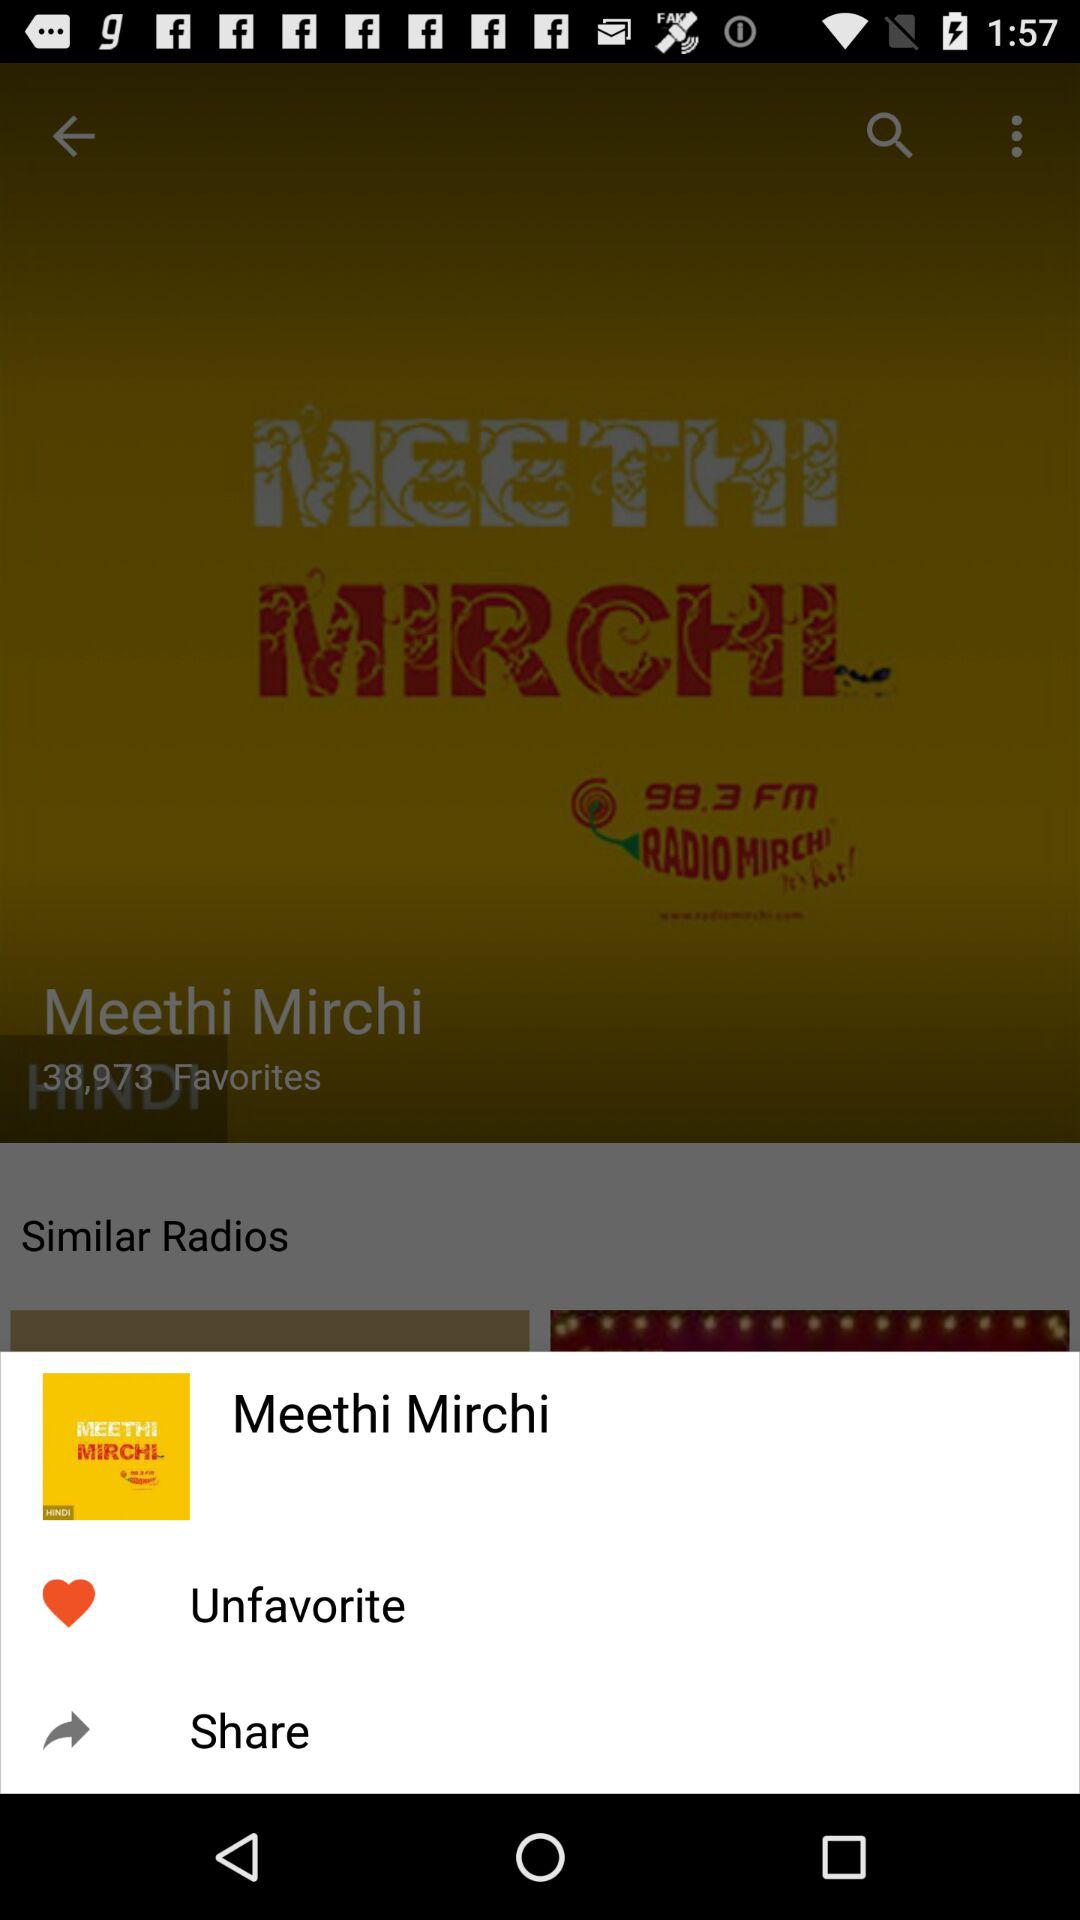How many people have marked "Meethi Mirchi" as a favorite? "Meethi Mirchi" has been marked as a favorite by 38,973 people. 